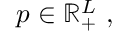<formula> <loc_0><loc_0><loc_500><loc_500>p \in \mathbb { R } _ { + } ^ { L } \ ,</formula> 